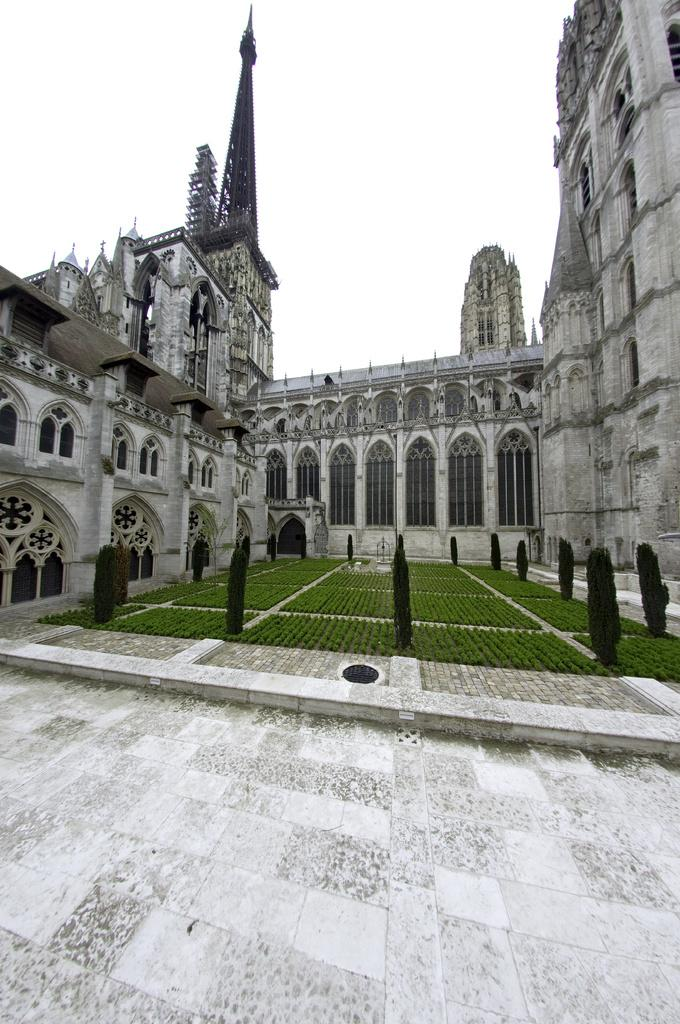What type of structures can be seen in the image? There are buildings in the image. What type of vegetation is present in the image? There is grass and shrubs in the image. What type of caption is written on the buildings in the image? There is no caption present on the buildings in the image. What type of suit can be seen hanging from the shrubs in the image? There is no suit present in the image; it only features buildings, grass, and shrubs. 